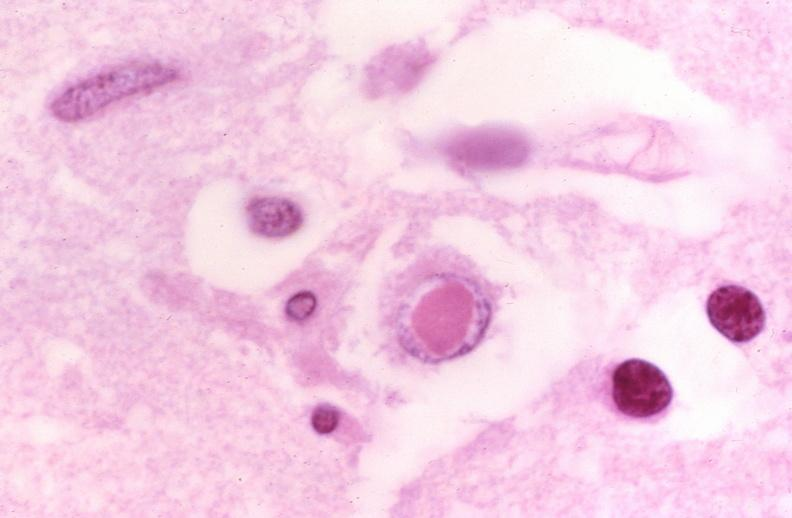s endocrine present?
Answer the question using a single word or phrase. No 